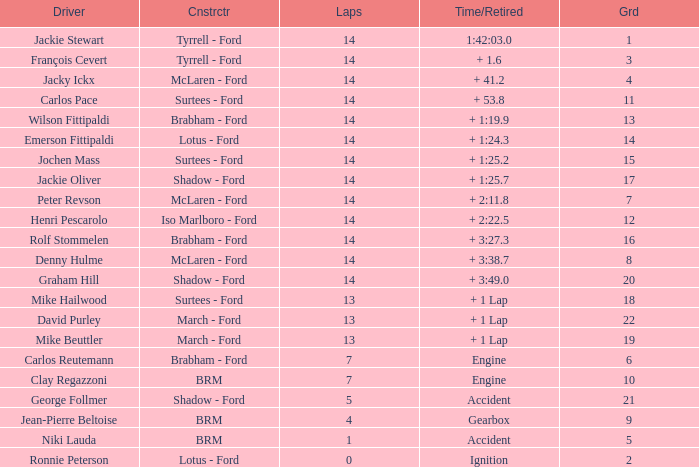What grad has a Time/Retired of + 1:24.3? 14.0. Could you parse the entire table as a dict? {'header': ['Driver', 'Cnstrctr', 'Laps', 'Time/Retired', 'Grd'], 'rows': [['Jackie Stewart', 'Tyrrell - Ford', '14', '1:42:03.0', '1'], ['François Cevert', 'Tyrrell - Ford', '14', '+ 1.6', '3'], ['Jacky Ickx', 'McLaren - Ford', '14', '+ 41.2', '4'], ['Carlos Pace', 'Surtees - Ford', '14', '+ 53.8', '11'], ['Wilson Fittipaldi', 'Brabham - Ford', '14', '+ 1:19.9', '13'], ['Emerson Fittipaldi', 'Lotus - Ford', '14', '+ 1:24.3', '14'], ['Jochen Mass', 'Surtees - Ford', '14', '+ 1:25.2', '15'], ['Jackie Oliver', 'Shadow - Ford', '14', '+ 1:25.7', '17'], ['Peter Revson', 'McLaren - Ford', '14', '+ 2:11.8', '7'], ['Henri Pescarolo', 'Iso Marlboro - Ford', '14', '+ 2:22.5', '12'], ['Rolf Stommelen', 'Brabham - Ford', '14', '+ 3:27.3', '16'], ['Denny Hulme', 'McLaren - Ford', '14', '+ 3:38.7', '8'], ['Graham Hill', 'Shadow - Ford', '14', '+ 3:49.0', '20'], ['Mike Hailwood', 'Surtees - Ford', '13', '+ 1 Lap', '18'], ['David Purley', 'March - Ford', '13', '+ 1 Lap', '22'], ['Mike Beuttler', 'March - Ford', '13', '+ 1 Lap', '19'], ['Carlos Reutemann', 'Brabham - Ford', '7', 'Engine', '6'], ['Clay Regazzoni', 'BRM', '7', 'Engine', '10'], ['George Follmer', 'Shadow - Ford', '5', 'Accident', '21'], ['Jean-Pierre Beltoise', 'BRM', '4', 'Gearbox', '9'], ['Niki Lauda', 'BRM', '1', 'Accident', '5'], ['Ronnie Peterson', 'Lotus - Ford', '0', 'Ignition', '2']]} 